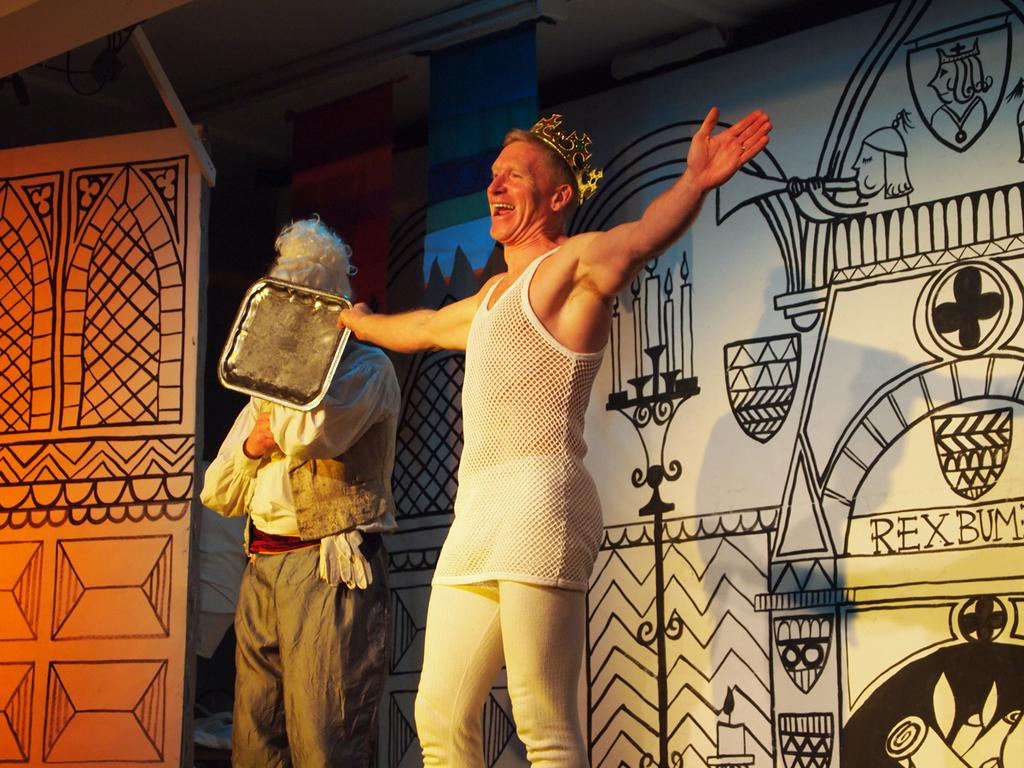How many people are in the image? There are people in the image, but the exact number cannot be determined from the provided facts. What is the person holding in the image? A person is holding an object in the image, but the specific object cannot be identified from the provided facts. What can be seen on the walls in the image? There are paintings on the walls in the image. What word is written on the person's pocket in the image? There is no mention of a word, pocket, or any writing in the provided facts. 